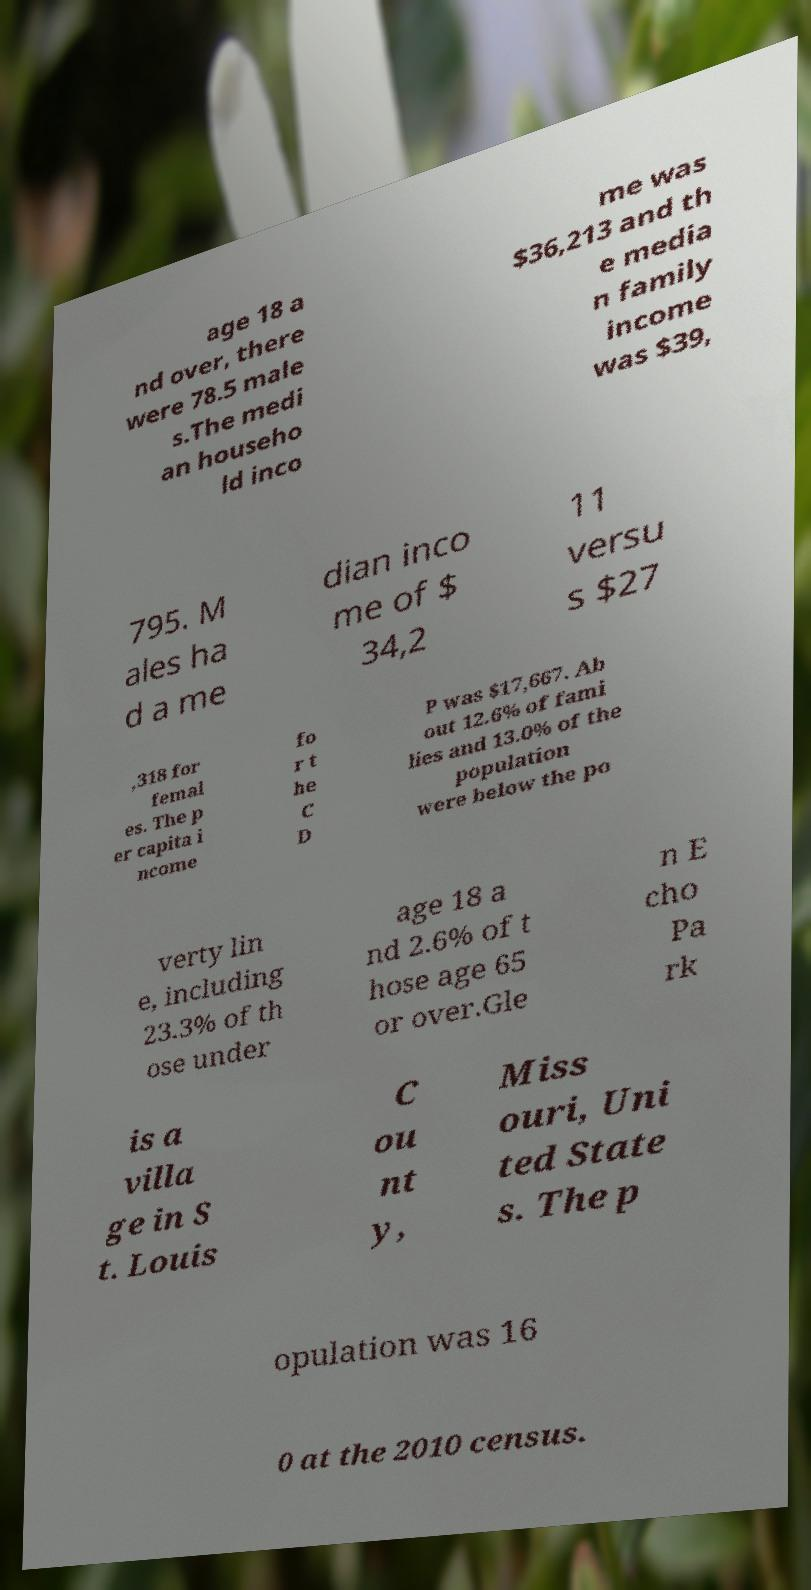There's text embedded in this image that I need extracted. Can you transcribe it verbatim? age 18 a nd over, there were 78.5 male s.The medi an househo ld inco me was $36,213 and th e media n family income was $39, 795. M ales ha d a me dian inco me of $ 34,2 11 versu s $27 ,318 for femal es. The p er capita i ncome fo r t he C D P was $17,667. Ab out 12.6% of fami lies and 13.0% of the population were below the po verty lin e, including 23.3% of th ose under age 18 a nd 2.6% of t hose age 65 or over.Gle n E cho Pa rk is a villa ge in S t. Louis C ou nt y, Miss ouri, Uni ted State s. The p opulation was 16 0 at the 2010 census. 